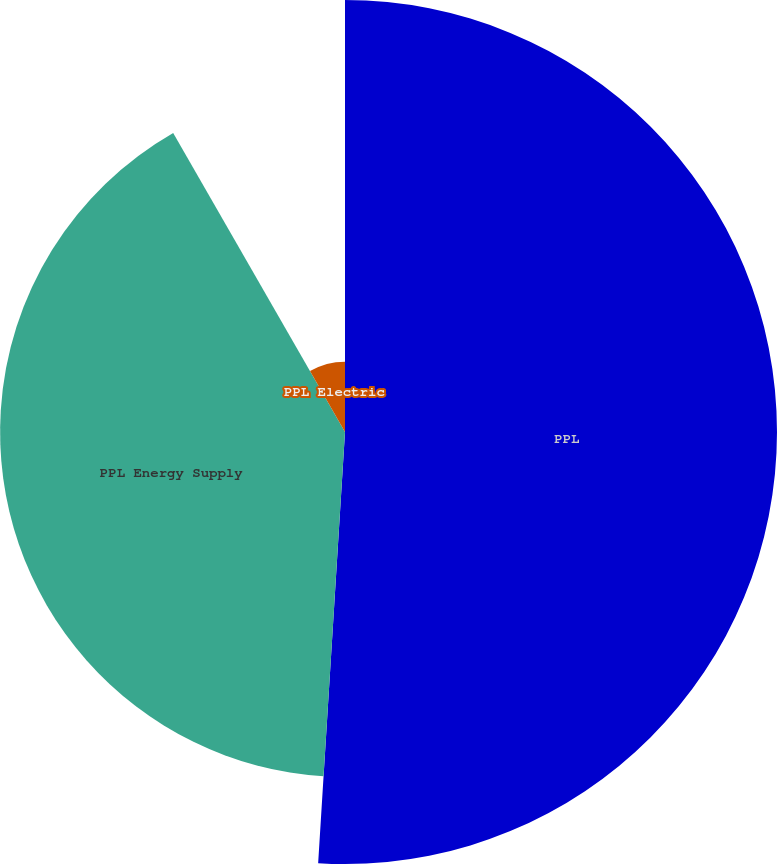Convert chart to OTSL. <chart><loc_0><loc_0><loc_500><loc_500><pie_chart><fcel>PPL<fcel>PPL Energy Supply<fcel>PPL Electric<nl><fcel>50.99%<fcel>40.71%<fcel>8.3%<nl></chart> 